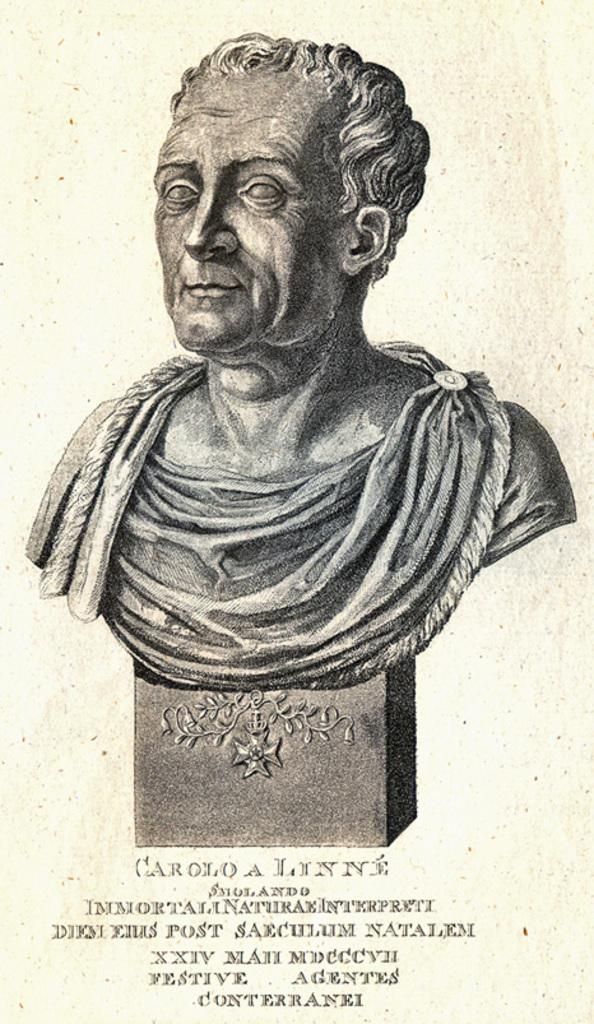What is the main subject of the image? The main subject of the image is a statue of a person. Can you describe the statue in the image? The statue is of a person. What color is the background of the image? The background of the image is cream colored. How many balls are being juggled by the statue in the image? There are no balls present in the image, as it features a statue of a person with no visible objects being juggled. 